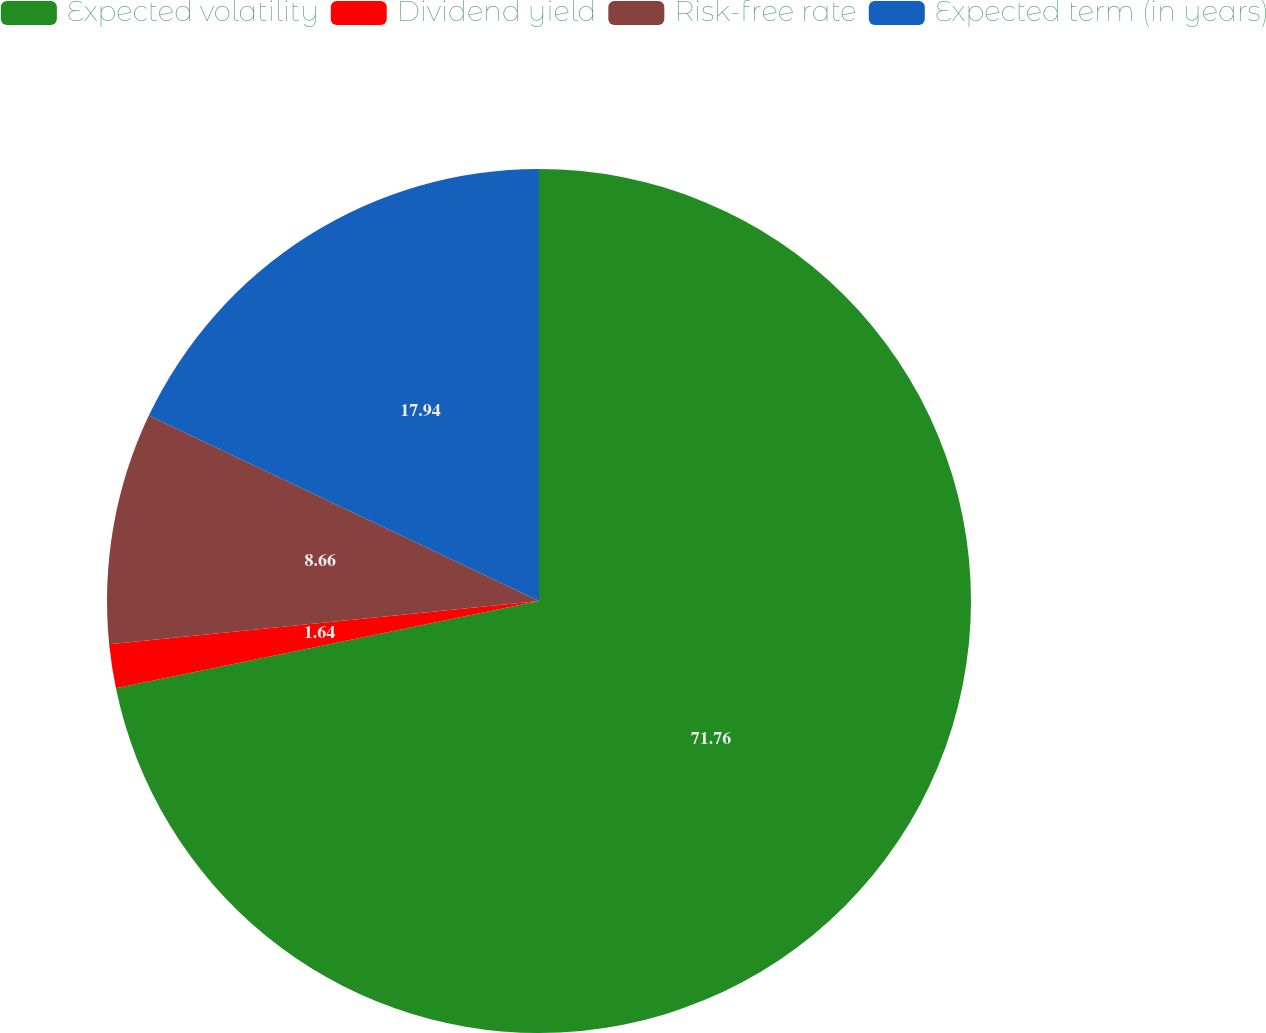Convert chart to OTSL. <chart><loc_0><loc_0><loc_500><loc_500><pie_chart><fcel>Expected volatility<fcel>Dividend yield<fcel>Risk-free rate<fcel>Expected term (in years)<nl><fcel>71.76%<fcel>1.64%<fcel>8.66%<fcel>17.94%<nl></chart> 